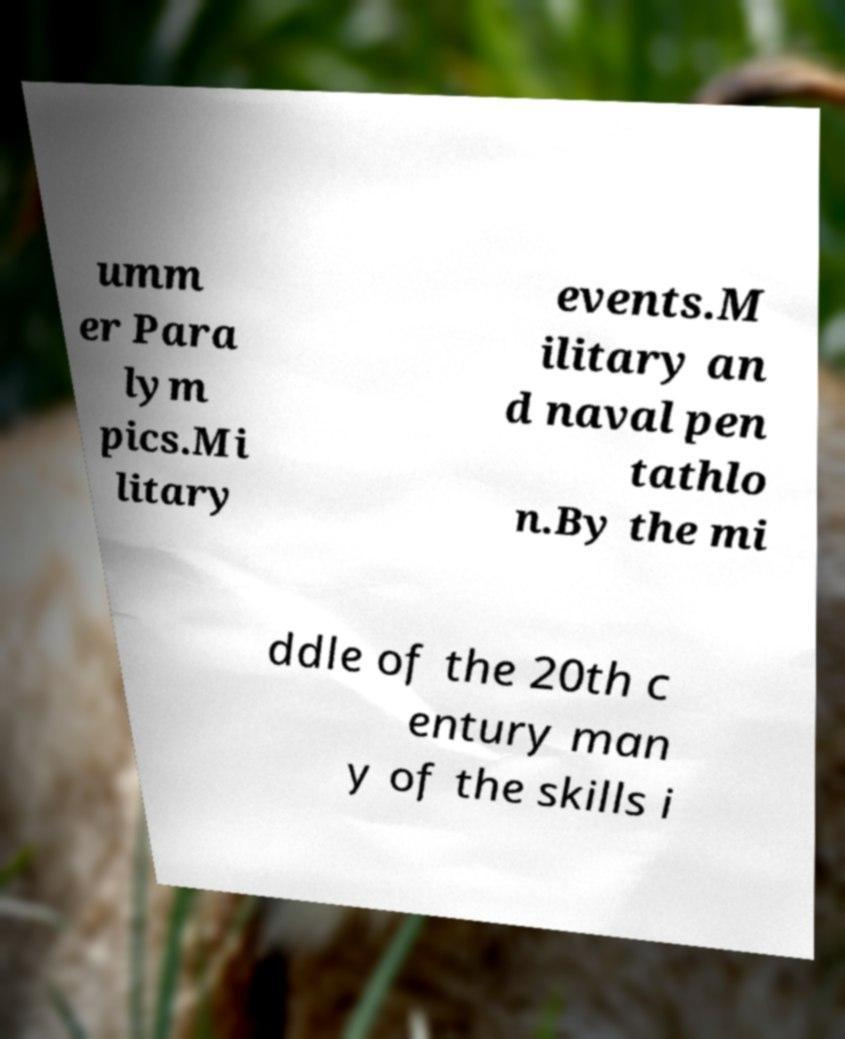Could you extract and type out the text from this image? umm er Para lym pics.Mi litary events.M ilitary an d naval pen tathlo n.By the mi ddle of the 20th c entury man y of the skills i 